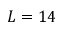Convert formula to latex. <formula><loc_0><loc_0><loc_500><loc_500>L = 1 4</formula> 